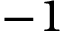Convert formula to latex. <formula><loc_0><loc_0><loc_500><loc_500>- 1</formula> 